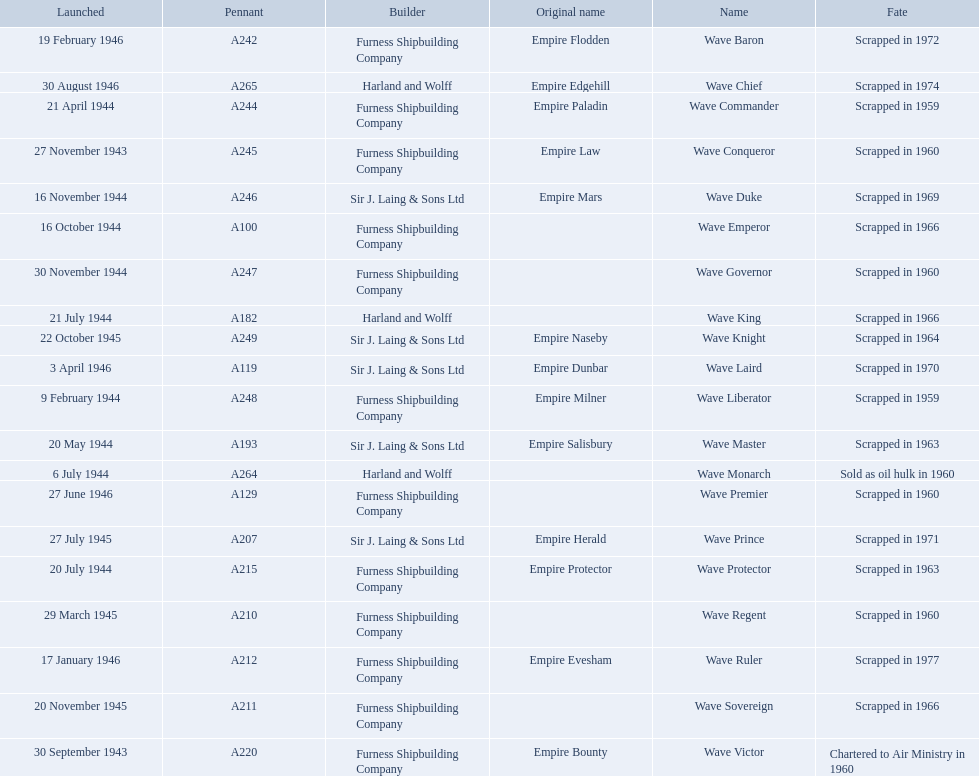What builders launched ships in november of any year? Furness Shipbuilding Company, Sir J. Laing & Sons Ltd, Furness Shipbuilding Company, Furness Shipbuilding Company. What ship builders ships had their original name's changed prior to scrapping? Furness Shipbuilding Company, Sir J. Laing & Sons Ltd. What was the name of the ship that was built in november and had its name changed prior to scrapping only 12 years after its launch? Wave Conqueror. 